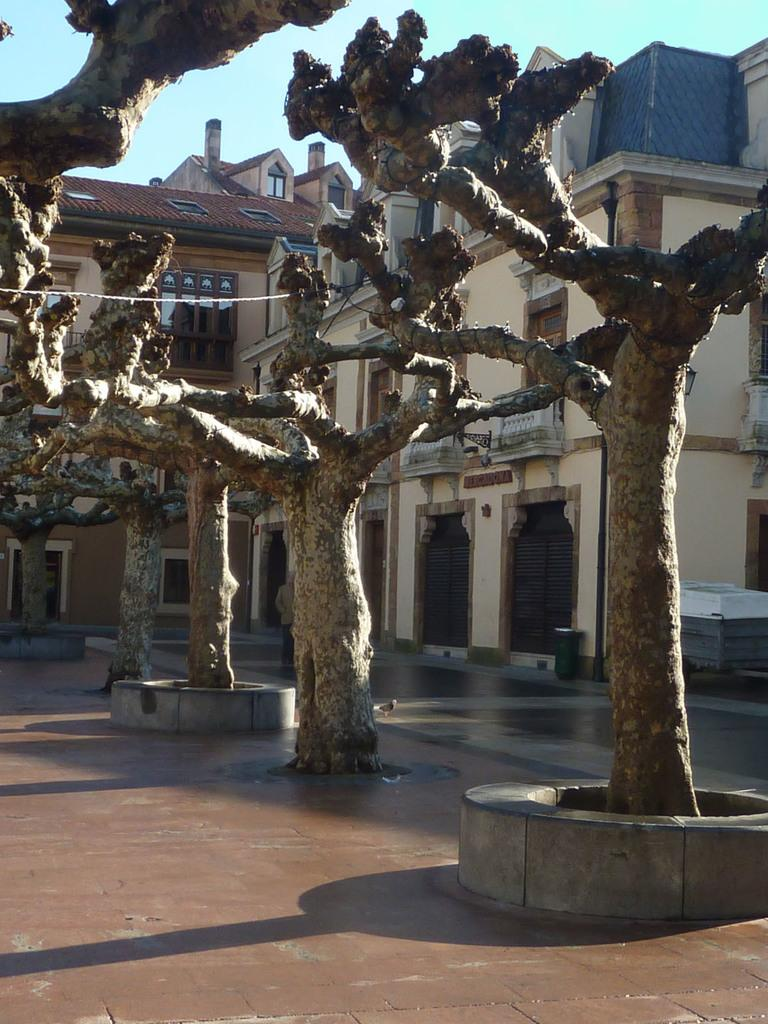What type of vegetation can be seen on the path in the image? There are trees on the path in the image. What structures are visible behind the trees? There are buildings visible behind the trees. What part of the natural environment is visible in the image? The sky is visible in the image. What type of animal can be seen learning in the image? There is no animal present in the image, and learning is not depicted. 